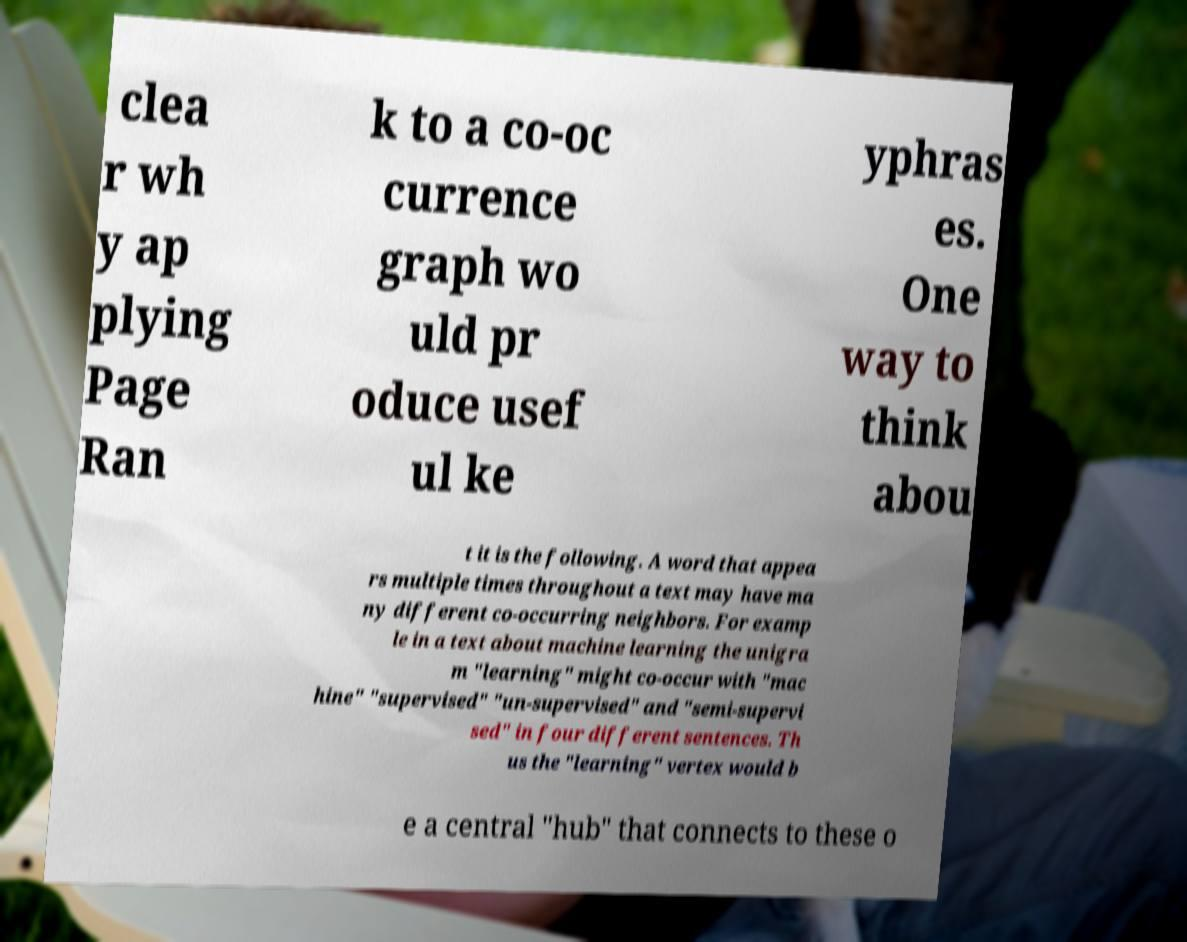There's text embedded in this image that I need extracted. Can you transcribe it verbatim? clea r wh y ap plying Page Ran k to a co-oc currence graph wo uld pr oduce usef ul ke yphras es. One way to think abou t it is the following. A word that appea rs multiple times throughout a text may have ma ny different co-occurring neighbors. For examp le in a text about machine learning the unigra m "learning" might co-occur with "mac hine" "supervised" "un-supervised" and "semi-supervi sed" in four different sentences. Th us the "learning" vertex would b e a central "hub" that connects to these o 